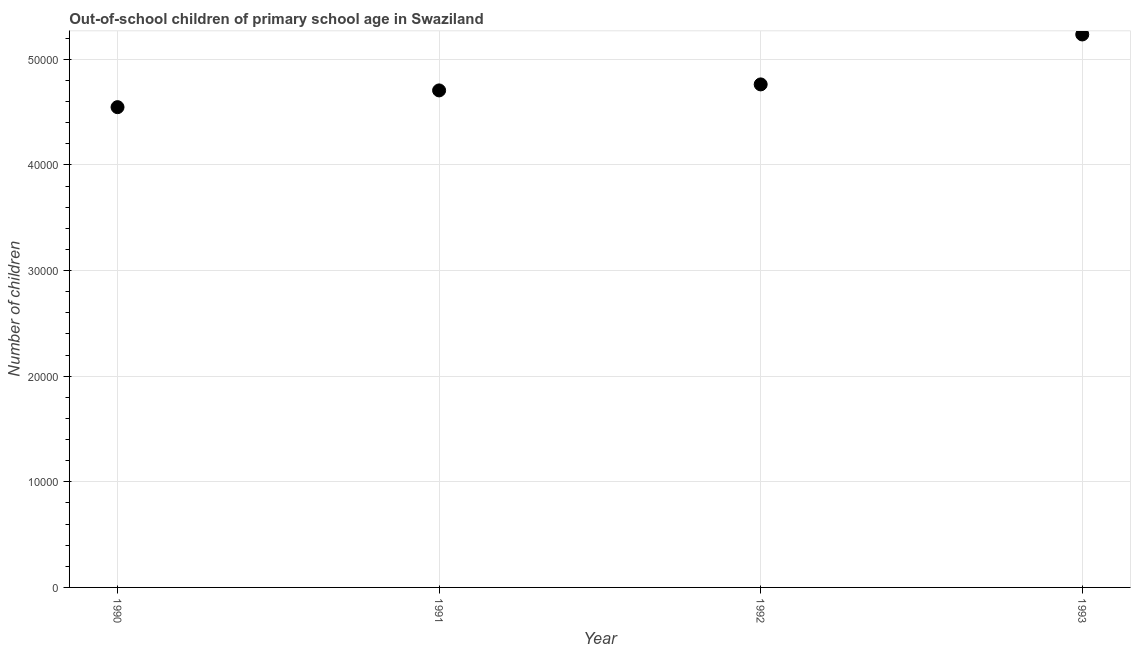What is the number of out-of-school children in 1990?
Keep it short and to the point. 4.55e+04. Across all years, what is the maximum number of out-of-school children?
Give a very brief answer. 5.24e+04. Across all years, what is the minimum number of out-of-school children?
Offer a terse response. 4.55e+04. In which year was the number of out-of-school children minimum?
Your response must be concise. 1990. What is the sum of the number of out-of-school children?
Provide a succinct answer. 1.93e+05. What is the difference between the number of out-of-school children in 1990 and 1991?
Your answer should be compact. -1585. What is the average number of out-of-school children per year?
Offer a terse response. 4.81e+04. What is the median number of out-of-school children?
Provide a short and direct response. 4.73e+04. What is the ratio of the number of out-of-school children in 1990 to that in 1991?
Ensure brevity in your answer.  0.97. Is the number of out-of-school children in 1990 less than that in 1993?
Offer a very short reply. Yes. Is the difference between the number of out-of-school children in 1990 and 1991 greater than the difference between any two years?
Offer a terse response. No. What is the difference between the highest and the second highest number of out-of-school children?
Make the answer very short. 4728. What is the difference between the highest and the lowest number of out-of-school children?
Your response must be concise. 6882. Does the number of out-of-school children monotonically increase over the years?
Provide a succinct answer. Yes. How many dotlines are there?
Your answer should be very brief. 1. Are the values on the major ticks of Y-axis written in scientific E-notation?
Offer a terse response. No. What is the title of the graph?
Give a very brief answer. Out-of-school children of primary school age in Swaziland. What is the label or title of the X-axis?
Provide a short and direct response. Year. What is the label or title of the Y-axis?
Your answer should be compact. Number of children. What is the Number of children in 1990?
Provide a short and direct response. 4.55e+04. What is the Number of children in 1991?
Give a very brief answer. 4.71e+04. What is the Number of children in 1992?
Keep it short and to the point. 4.76e+04. What is the Number of children in 1993?
Your response must be concise. 5.24e+04. What is the difference between the Number of children in 1990 and 1991?
Offer a very short reply. -1585. What is the difference between the Number of children in 1990 and 1992?
Ensure brevity in your answer.  -2154. What is the difference between the Number of children in 1990 and 1993?
Ensure brevity in your answer.  -6882. What is the difference between the Number of children in 1991 and 1992?
Provide a succinct answer. -569. What is the difference between the Number of children in 1991 and 1993?
Provide a succinct answer. -5297. What is the difference between the Number of children in 1992 and 1993?
Provide a succinct answer. -4728. What is the ratio of the Number of children in 1990 to that in 1992?
Give a very brief answer. 0.95. What is the ratio of the Number of children in 1990 to that in 1993?
Your answer should be very brief. 0.87. What is the ratio of the Number of children in 1991 to that in 1992?
Your answer should be compact. 0.99. What is the ratio of the Number of children in 1991 to that in 1993?
Ensure brevity in your answer.  0.9. What is the ratio of the Number of children in 1992 to that in 1993?
Provide a short and direct response. 0.91. 